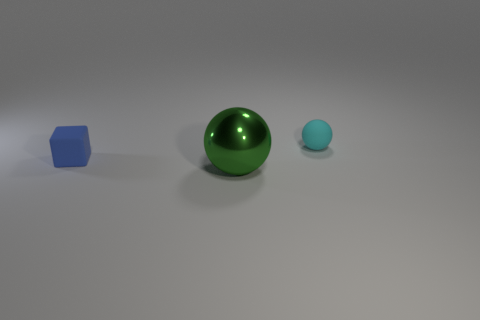Add 1 small matte cubes. How many objects exist? 4 Subtract all blocks. How many objects are left? 2 Subtract all green balls. How many balls are left? 1 Subtract all green objects. Subtract all rubber things. How many objects are left? 0 Add 2 metal things. How many metal things are left? 3 Add 3 green things. How many green things exist? 4 Subtract 0 yellow spheres. How many objects are left? 3 Subtract all yellow cubes. Subtract all green cylinders. How many cubes are left? 1 Subtract all gray cylinders. How many purple cubes are left? 0 